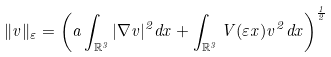Convert formula to latex. <formula><loc_0><loc_0><loc_500><loc_500>\| v \| _ { \varepsilon } = \left ( a \int _ { \mathbb { R } ^ { 3 } } | \nabla v | ^ { 2 } d x + \int _ { \mathbb { R } ^ { 3 } } V ( \varepsilon x ) v ^ { 2 } d x \right ) ^ { \frac { 1 } { 2 } }</formula> 